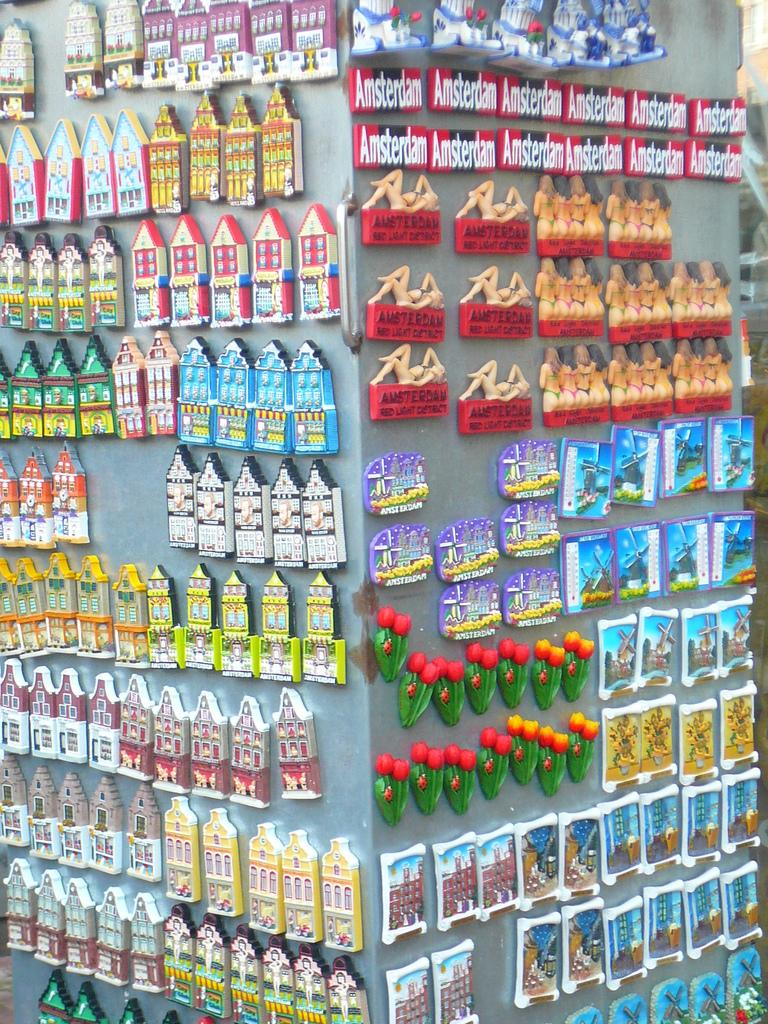What material is the main object in the image made of? The main object in the image is a metal sheet. Are there any other objects attached to the metal sheet? Yes, there are objects in the image that look like magnets attached to the metal sheet. What type of pen can be seen writing on the metal sheet in the image? There is no pen present in the image, and the magnets are not writing on the metal sheet. 